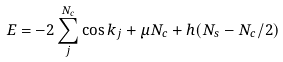Convert formula to latex. <formula><loc_0><loc_0><loc_500><loc_500>E = - 2 \sum _ { j } ^ { N _ { c } } \cos k _ { j } + \mu N _ { c } + h ( N _ { s } - N _ { c } / 2 )</formula> 